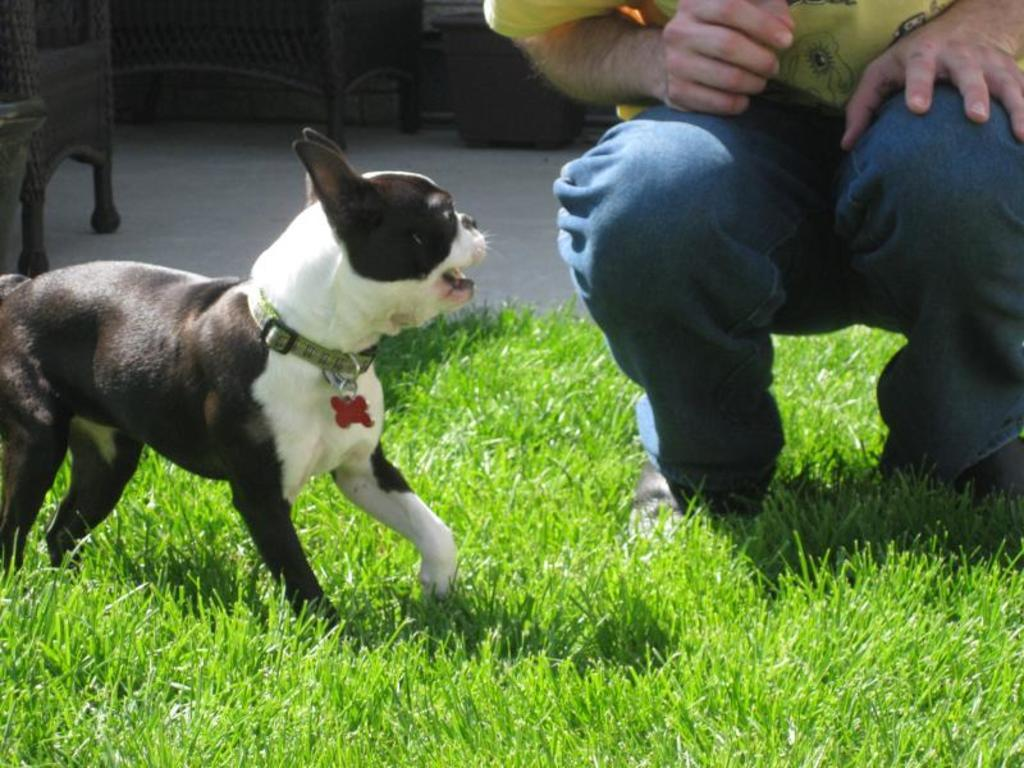What type of animal can be seen in the image? There is a dog in the image. What is the man doing in the image? The man is in a squat position in the image. What type of surface is visible in the image? There is grass visible in the image. What else can be seen on the floor in the image? There are other objects on the floor in the image. What type of pencil is the dog holding in the image? There is no pencil present in the image, and the dog is not holding anything. 